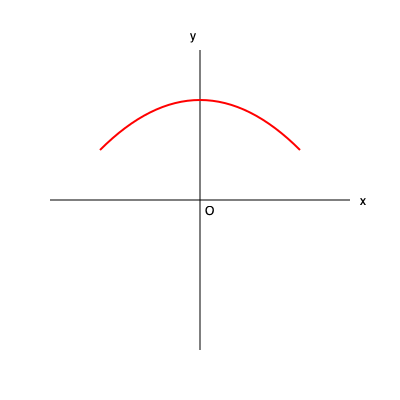In the coordinate plane above, an ideal eyebrow shape is represented by the curve. If the curve is modeled by the quadratic function $f(x)=ax^2+bx+c$, where the vertex is at (0, 100) and the y-intercept is at (0, 0), what is the value of $a$? Let's approach this step-by-step:

1) The general form of a quadratic function is $f(x)=ax^2+bx+c$.

2) We're given that the vertex is at (0, 100). For a quadratic function in the form $f(x)=a(x-h)^2+k$, (h,k) represents the vertex. So our function can be written as:

   $f(x)=a(x-0)^2+100 = ax^2+100$

3) We're also told that the y-intercept is at (0, 0). This means when x = 0, y should equal 0:

   $f(0) = a(0)^2 + 100 = 100 = 0$

4) From this, we can deduce that $a$ must be negative, because the parabola opens downward.

5) To find the exact value of $a$, we can use the point (100, 0), which is on the curve:

   $0 = a(100)^2 + 100$
   $0 = 10000a + 100$
   $-100 = 10000a$
   $a = -\frac{1}{100} = -0.01$

Therefore, the value of $a$ is $-0.01$.
Answer: $-0.01$ 